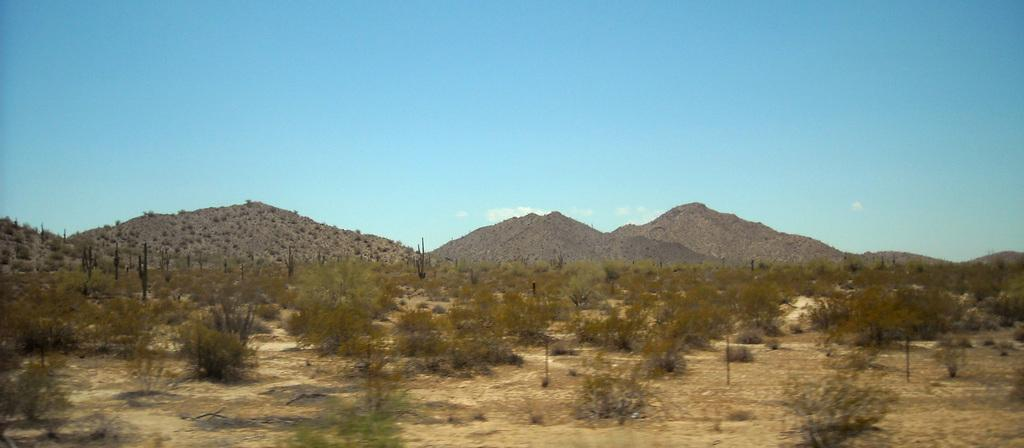What type of natural landform can be seen in the image? There are mountains in the image. What type of vegetation is present in the image? There are trees in the image. What is the condition of the ground in the image? Dry grass is present in the image. What colors can be seen in the sky in the image? The sky is blue and white in color. How many toes can be seen in the image? There are no toes visible in the image. What type of field is present in the image? There is no field present in the image; it features mountains, trees, dry grass, and a blue and white sky. 